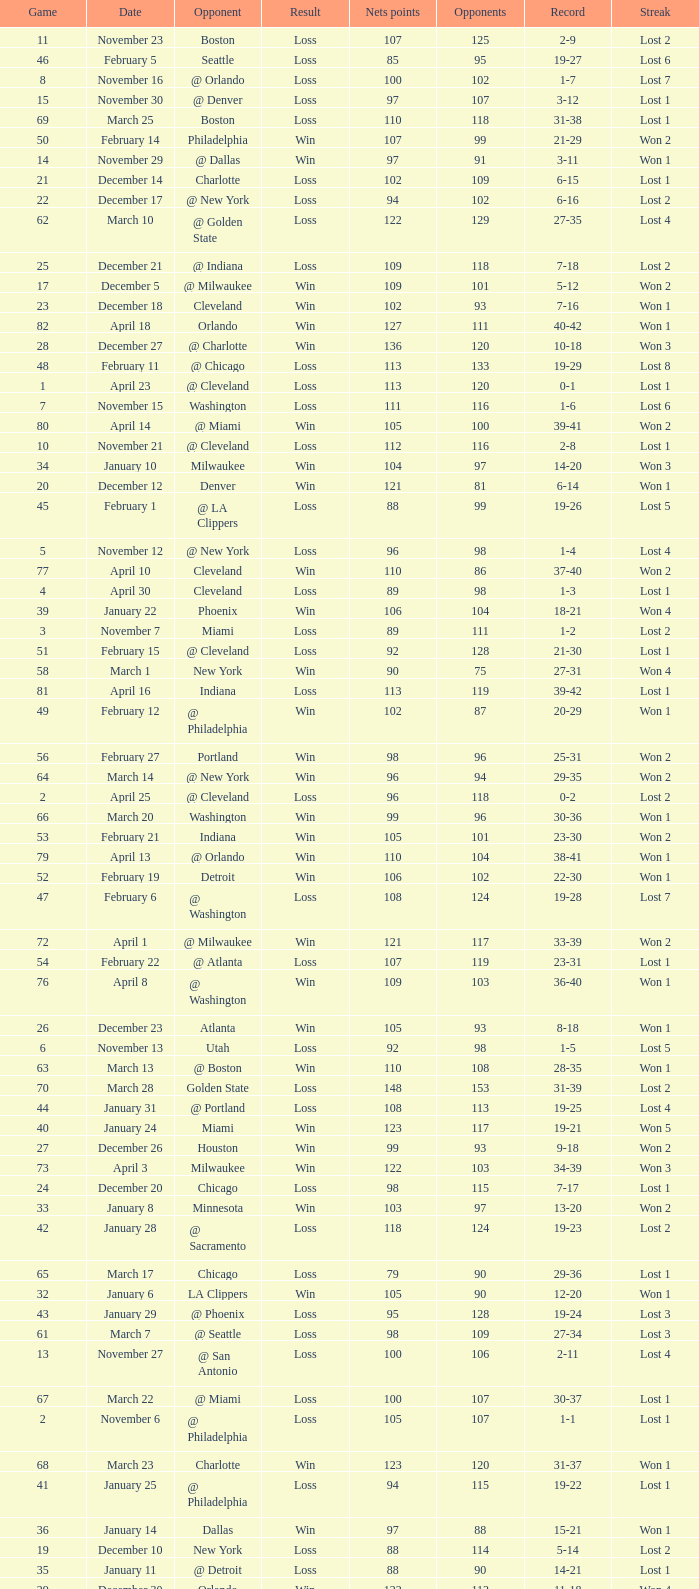How many games had fewer than 118 opponents and more than 109 net points with an opponent of Washington? 1.0. 